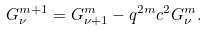Convert formula to latex. <formula><loc_0><loc_0><loc_500><loc_500>G _ { \nu } ^ { m + 1 } = G _ { \nu + 1 } ^ { m } - q ^ { 2 m } c ^ { 2 } G _ { \nu } ^ { m } .</formula> 